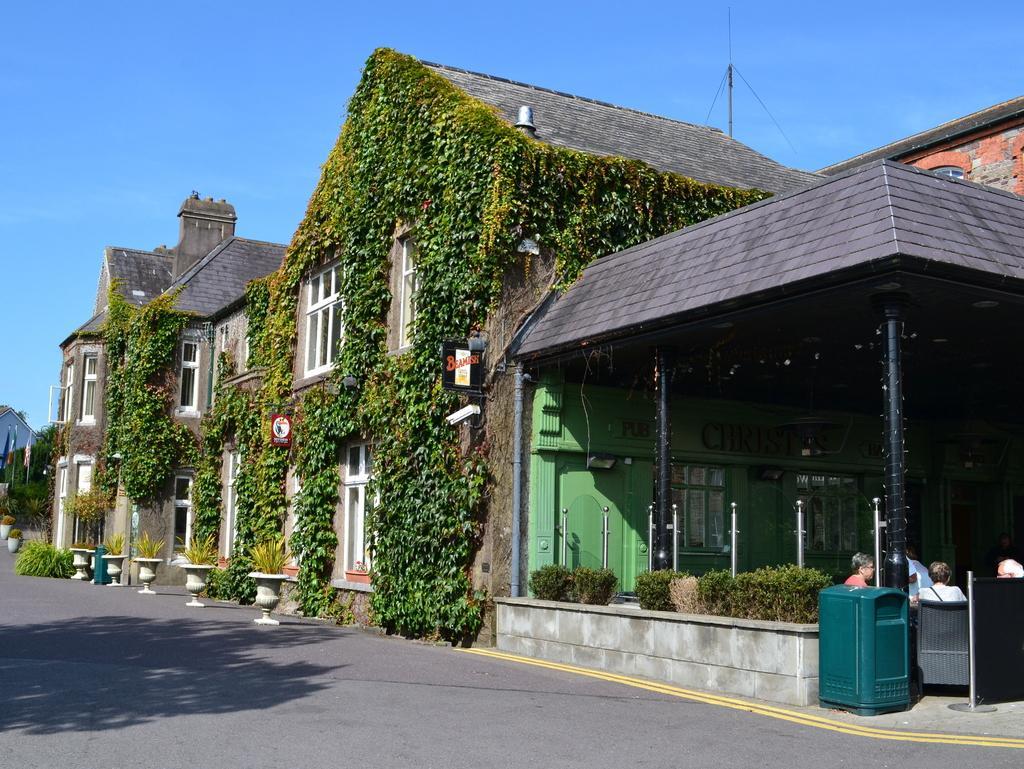Can you describe this image briefly? In this picture we can see the road, potts, poles, plants, flags, some people are sitting on chairs, buildings with windows, some objects and in the background we can see the sky. 